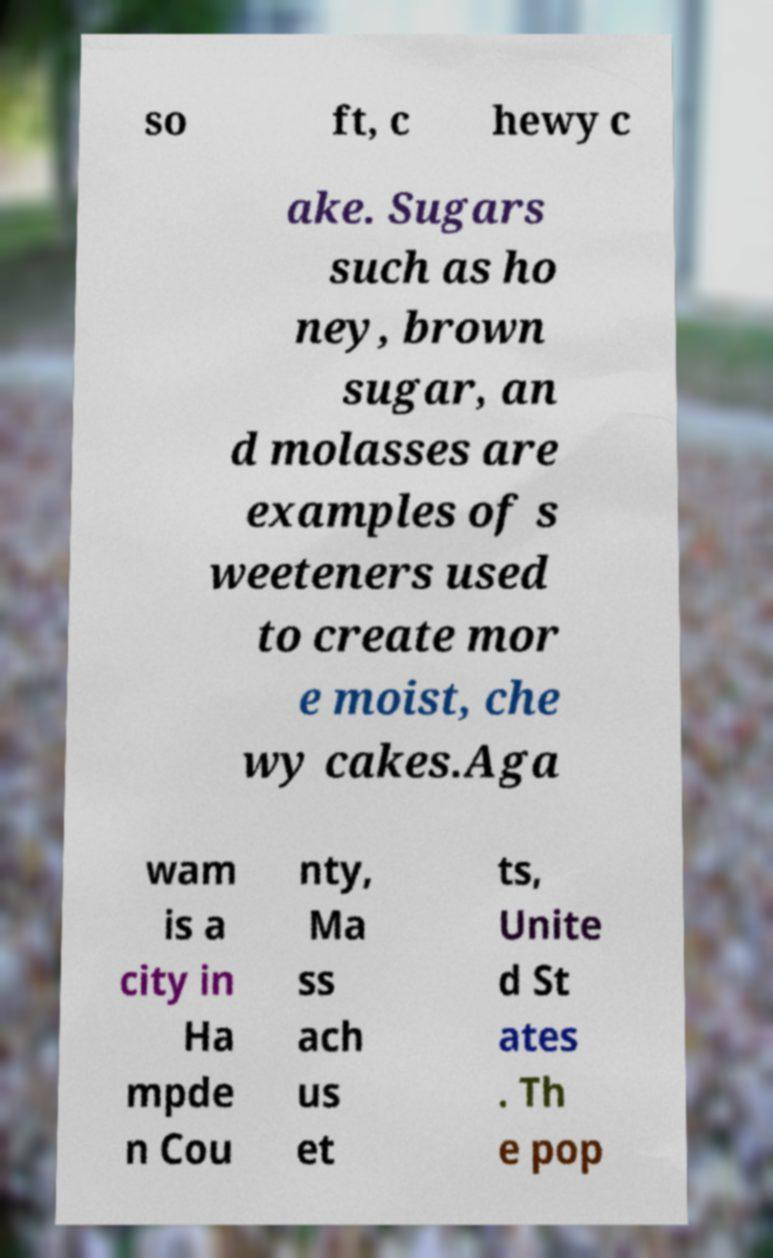Please identify and transcribe the text found in this image. so ft, c hewy c ake. Sugars such as ho ney, brown sugar, an d molasses are examples of s weeteners used to create mor e moist, che wy cakes.Aga wam is a city in Ha mpde n Cou nty, Ma ss ach us et ts, Unite d St ates . Th e pop 